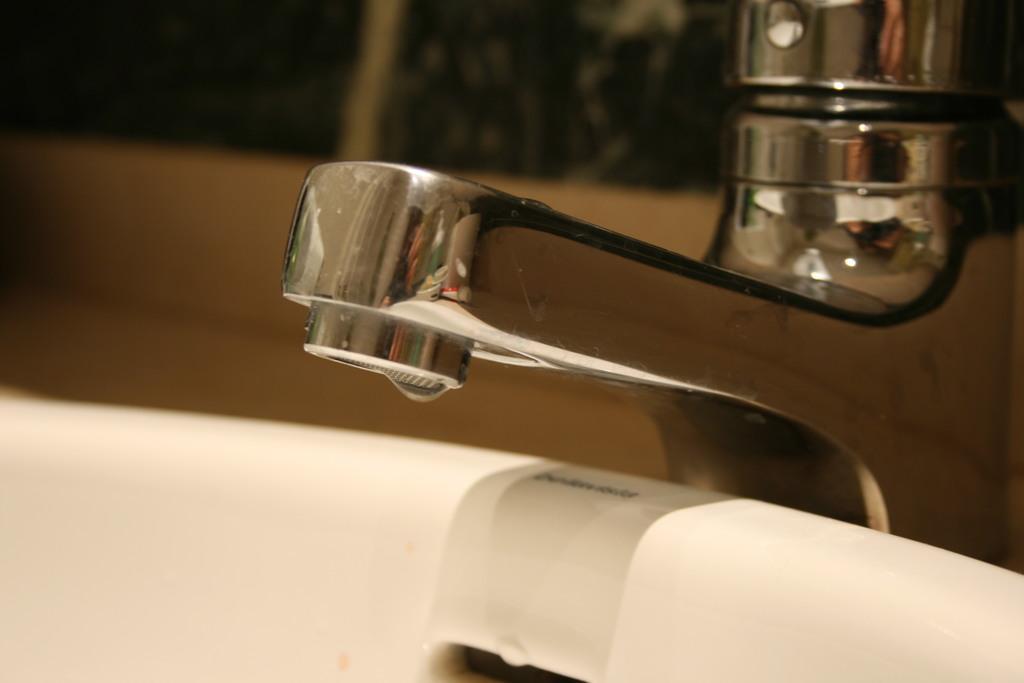In one or two sentences, can you explain what this image depicts? In this image there is a sink in the middle. At the top of the sink there is a metal tap. 